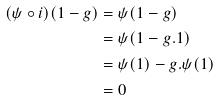Convert formula to latex. <formula><loc_0><loc_0><loc_500><loc_500>( \psi \circ i ) ( 1 - g ) & = \psi ( 1 - g ) \\ & = \psi ( 1 - g . 1 ) \\ & = \psi ( 1 ) - g . \psi ( 1 ) \\ & = 0</formula> 